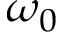Convert formula to latex. <formula><loc_0><loc_0><loc_500><loc_500>\omega _ { 0 }</formula> 